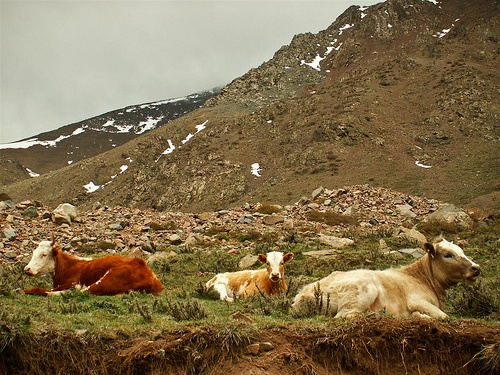Describe the objects in this image and their specific colors. I can see cow in darkgray, tan, and olive tones, cow in darkgray, maroon, and brown tones, and cow in darkgray, beige, tan, khaki, and brown tones in this image. 